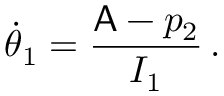<formula> <loc_0><loc_0><loc_500><loc_500>\dot { \theta } _ { 1 } = \frac { A - p _ { 2 } } { I _ { 1 } } \, .</formula> 